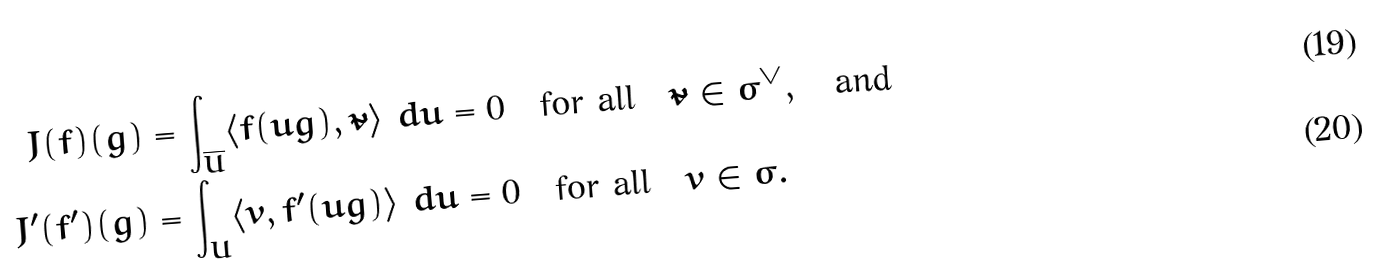Convert formula to latex. <formula><loc_0><loc_0><loc_500><loc_500>J ( f ) ( g ) & = \int _ { \overline { U } } \langle f ( \bar { u } g ) , \tilde { v } \rangle \ d \bar { u } = 0 \quad \text {for all} \quad \tilde { v } \in \sigma ^ { \vee } , \quad \text {and} \\ J ^ { \prime } ( f ^ { \prime } ) ( g ) & = \int _ { U } \langle v , f ^ { \prime } ( u g ) \rangle \ d u = 0 \quad \text {for all} \quad v \in \sigma .</formula> 